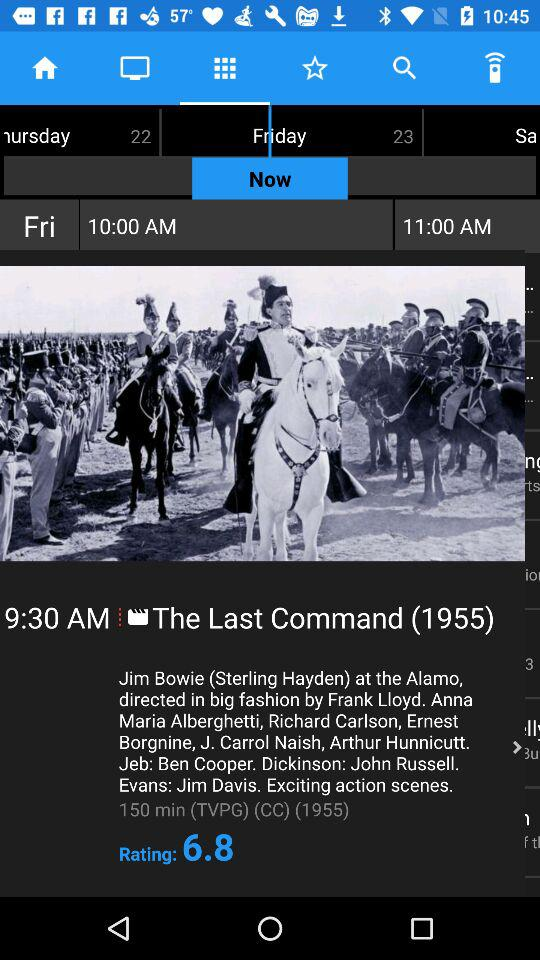What is the time of the movie? The time is 9:30 a.m. 